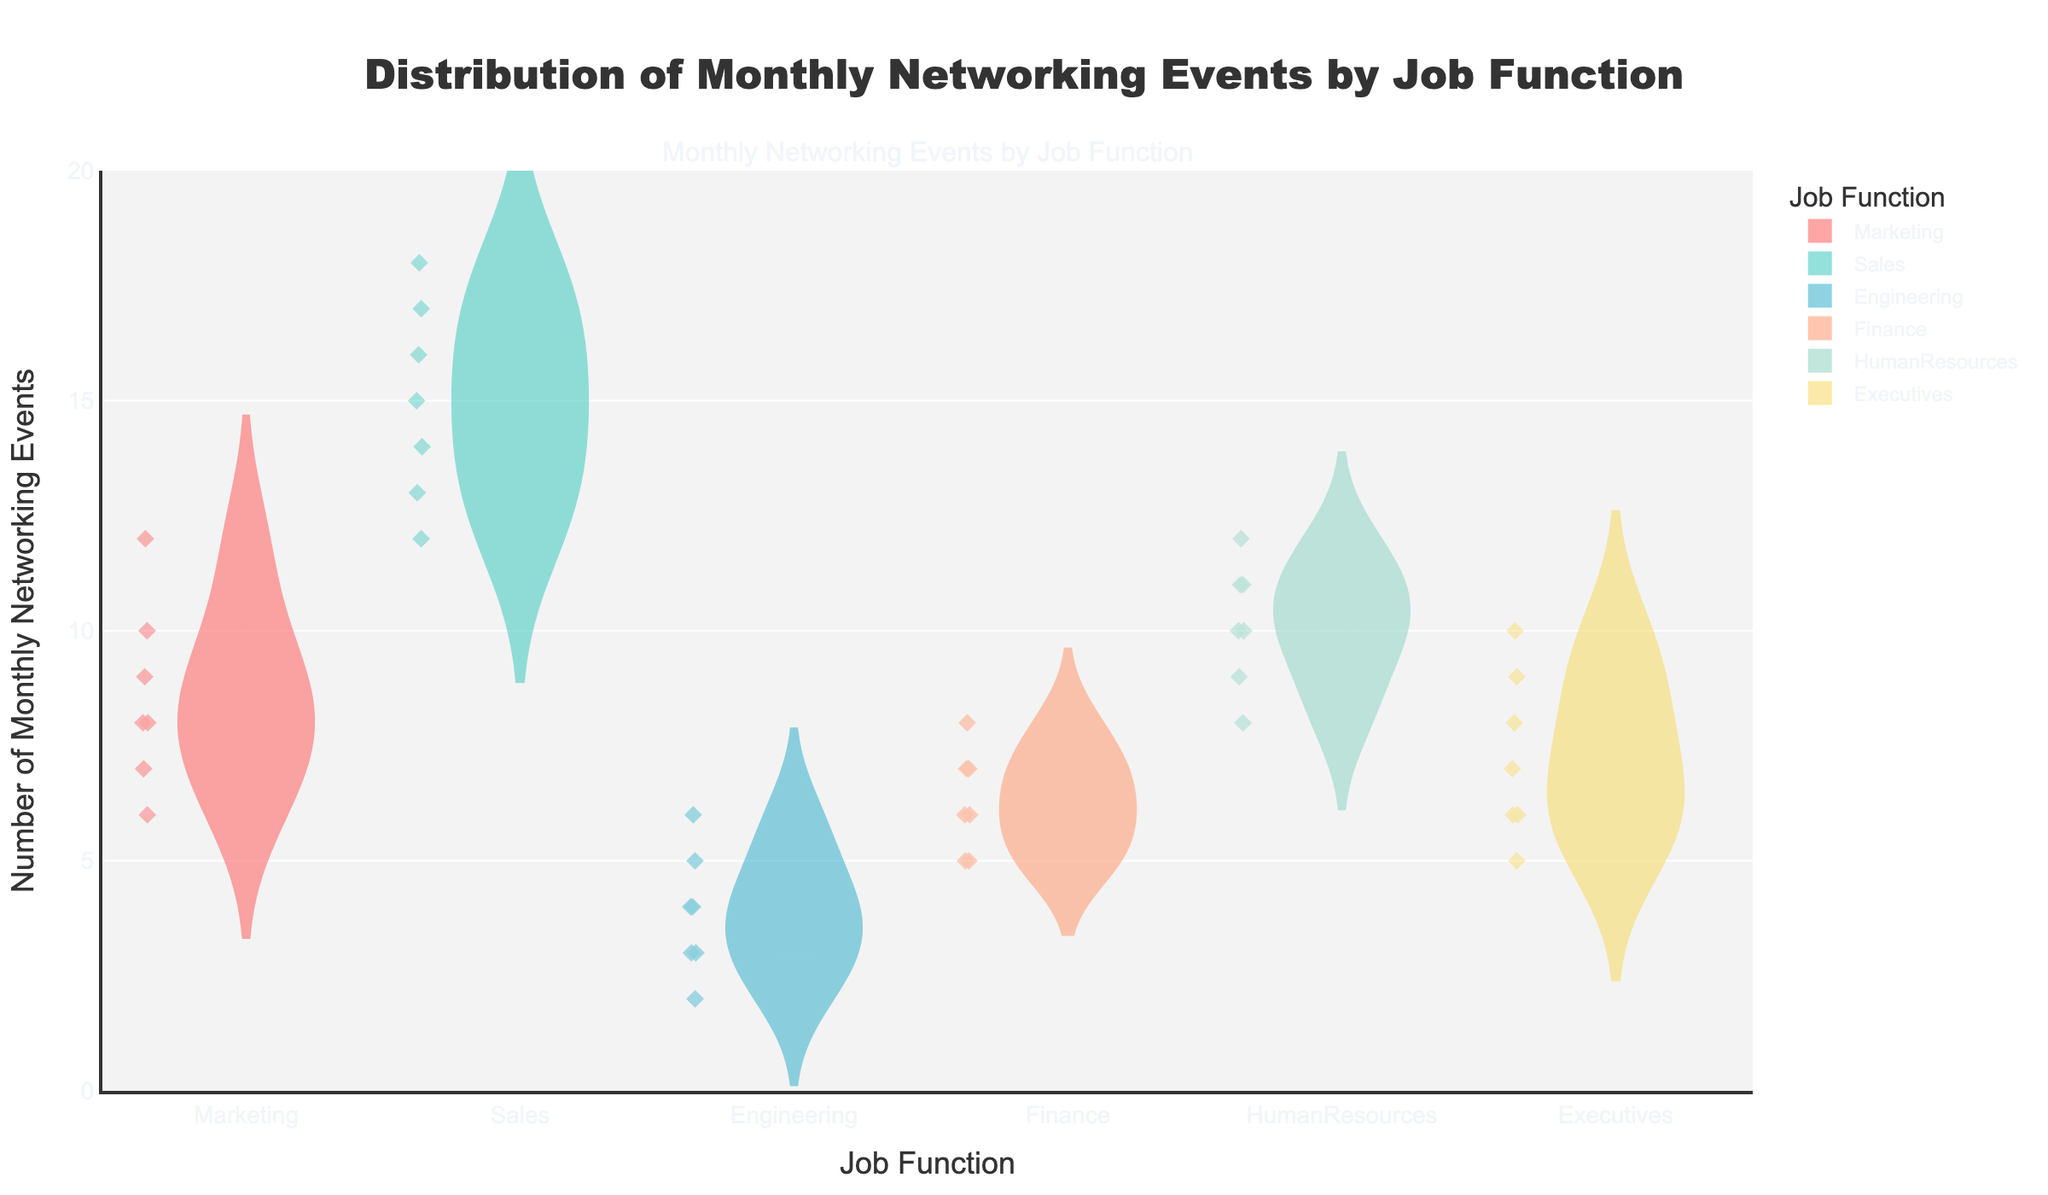What is the title of the figure? The title of the figure is placed at the top and reads "Distribution of Monthly Networking Events by Job Function".
Answer: Distribution of Monthly Networking Events by Job Function How many job functions are represented in the plot? Each unique slot in the violin plot represents a job function; there are six different slots, so there are six job functions.
Answer: Six Which job function has the highest median number of monthly networking events? To find the median, look for the line inside each violin plot. Sales has the highest median because the line is positioned higher on the y-axis compared to other job functions.
Answer: Sales What is the range of monthly networking events for the Marketing job function? The range is the difference between the maximum and minimum points seen in the violin plot for Marketing. For Marketing, the minimum value is 6, and the maximum value is 12. Therefore, the range is 12 - 6.
Answer: 6 Which job function has the lowest median number of monthly networking events? The median is represented by the white line within each violin plot. Engineering has the lowest median as its line is the lowest among all the job functions.
Answer: Engineering What are the colors used for the different job functions in the plot? Observing the violin plots, the colors used are red for Marketing, teal for Sales, light blue for Engineering, orange for Finance, light green for Human Resources, and yellow for Executives.
Answer: Red, teal, light blue, orange, light green, yellow How does the distribution of monthly networking events in Finance compare to that in Executives? Both distributions show a similar range and spread, with both having minimum values around 5 and maximum values around 10, but the density and concentration slightly differ.
Answer: Similar range, slight differences in density What is the average of the median number of monthly networking events for all job functions combined? Identify the medians from the violin plots: Marketing (8.5), Sales (15.5), Engineering (3.5), Finance (6), Human Resources (10), Executives (7). Sum these values and divide by the number of job functions (6). Average = (8.5 + 15.5 + 3.5 + 6 + 10 + 7) / 6.
Answer: 8.75 Between Marketing and Human Resources, which job function shows greater variability in monthly networking events? Variability can be assessed by looking at the width and spread of the violins. Human Resources shows greater width and spread compared to Marketing, indicating more variability.
Answer: Human Resources 